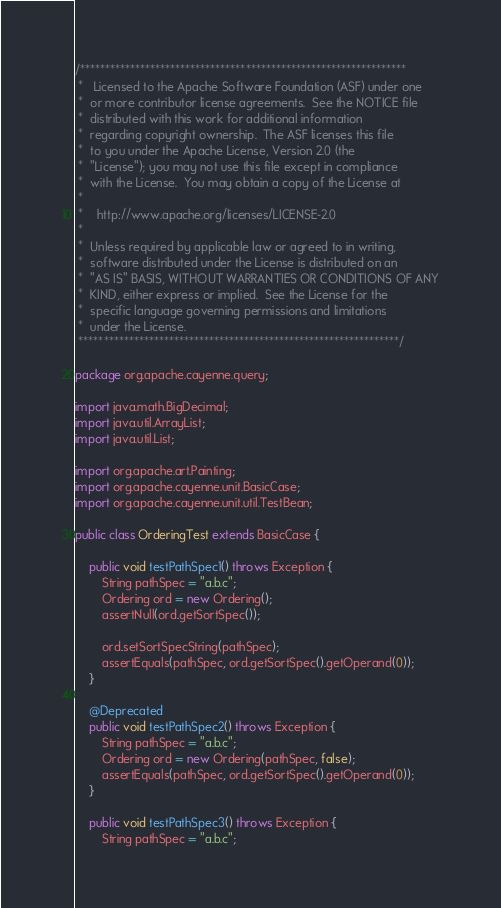<code> <loc_0><loc_0><loc_500><loc_500><_Java_>/*****************************************************************
 *   Licensed to the Apache Software Foundation (ASF) under one
 *  or more contributor license agreements.  See the NOTICE file
 *  distributed with this work for additional information
 *  regarding copyright ownership.  The ASF licenses this file
 *  to you under the Apache License, Version 2.0 (the
 *  "License"); you may not use this file except in compliance
 *  with the License.  You may obtain a copy of the License at
 *
 *    http://www.apache.org/licenses/LICENSE-2.0
 *
 *  Unless required by applicable law or agreed to in writing,
 *  software distributed under the License is distributed on an
 *  "AS IS" BASIS, WITHOUT WARRANTIES OR CONDITIONS OF ANY
 *  KIND, either express or implied.  See the License for the
 *  specific language governing permissions and limitations
 *  under the License.
 ****************************************************************/

package org.apache.cayenne.query;

import java.math.BigDecimal;
import java.util.ArrayList;
import java.util.List;

import org.apache.art.Painting;
import org.apache.cayenne.unit.BasicCase;
import org.apache.cayenne.unit.util.TestBean;

public class OrderingTest extends BasicCase {

    public void testPathSpec1() throws Exception {
        String pathSpec = "a.b.c";
        Ordering ord = new Ordering();
        assertNull(ord.getSortSpec());

        ord.setSortSpecString(pathSpec);
        assertEquals(pathSpec, ord.getSortSpec().getOperand(0));
    }

    @Deprecated
    public void testPathSpec2() throws Exception {
        String pathSpec = "a.b.c";
        Ordering ord = new Ordering(pathSpec, false);
        assertEquals(pathSpec, ord.getSortSpec().getOperand(0));
    }

    public void testPathSpec3() throws Exception {
        String pathSpec = "a.b.c";</code> 